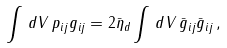<formula> <loc_0><loc_0><loc_500><loc_500>\int \, d V \, p _ { i j } g _ { i j } = 2 \bar { \eta } _ { d } \int \, d V \, \bar { g } _ { i j } \bar { g } _ { i j } \, ,</formula> 